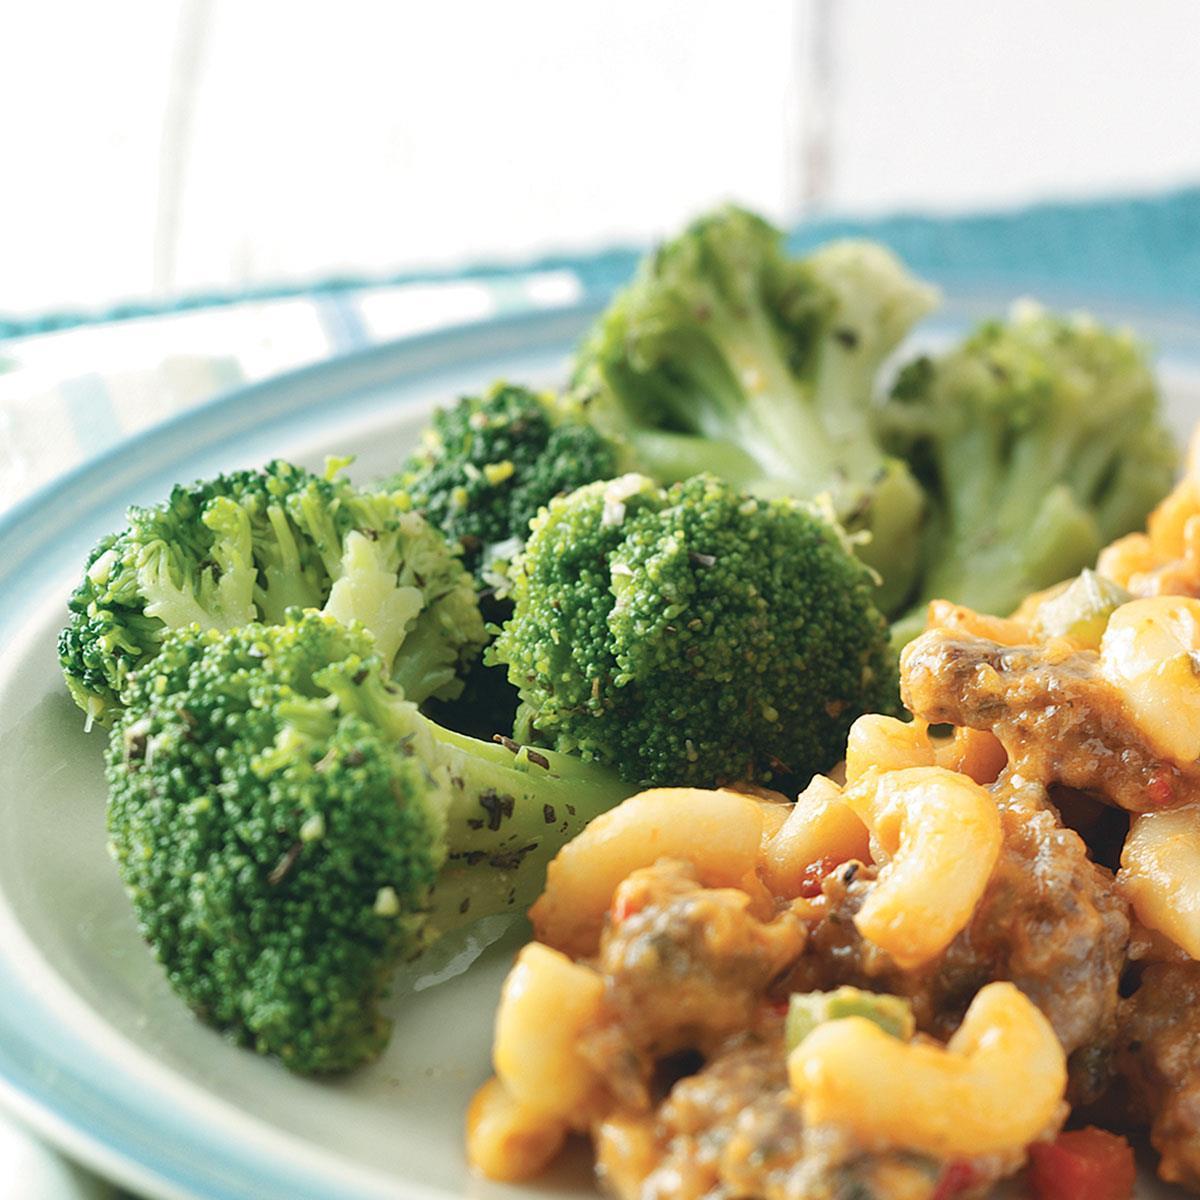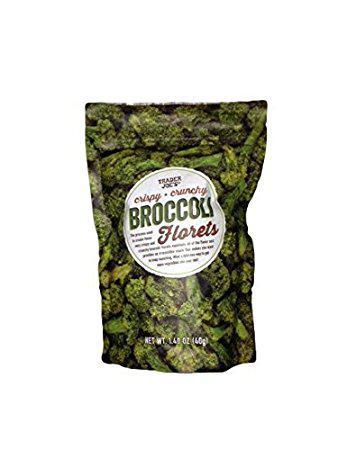The first image is the image on the left, the second image is the image on the right. Examine the images to the left and right. Is the description "One image shows broccoli florets still in the store packaging with a label on the front." accurate? Answer yes or no. Yes. The first image is the image on the left, the second image is the image on the right. For the images shown, is this caption "The broccoli in one of the images is still in the bag." true? Answer yes or no. Yes. 